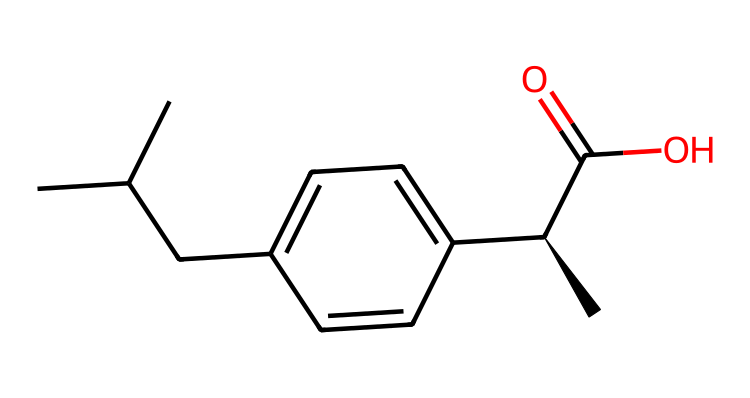What is the total number of carbon atoms in ibuprofen? Count the carbon atoms represented in the SMILES notation. There are 13 carbon atoms present in the structure (CC(C)C indicates 3, and c1ccc(cc1) adds another 6 carbons, along with additional 4 from the rest).
Answer: 13 How many double bonds are present in the structure? Examine the structure represented in the SMILES; there is one double bond between the carbon and oxygen in the carboxylic acid group (C(=O)) and no other double bonds are visible.
Answer: 1 What type of functional group is present in ibuprofen? Identify the main functional groups based on the structure. The presence of C(=O) and -OH indicates a carboxylic acid functional group.
Answer: carboxylic acid Is ibuprofen a polar or non-polar compound? Consider the presence of the polar carboxylic acid group versus the non-polar hydrocarbon part of the molecule. While there is a polar character due to the -COOH, overall, ibuprofen is more non-polar because of its larger hydrocarbon structure.
Answer: non-polar From which isomeric form does ibuprofen derive its chirality? In the SMILES code, the notation [C@H] suggests the presence of a chiral center. This indicates that ibuprofen has a specific isomeric form that is responsible for its activity.
Answer: S-isomer What does the presence of aromatic rings indicate about ibuprofen? The presence of 'c' in the SMILES notation indicates that the compound contains aromatic carbon rings, which typically contributes to the stability and specific chemical reactivity of ibuprofen as a molecule.
Answer: stability and reactivity 